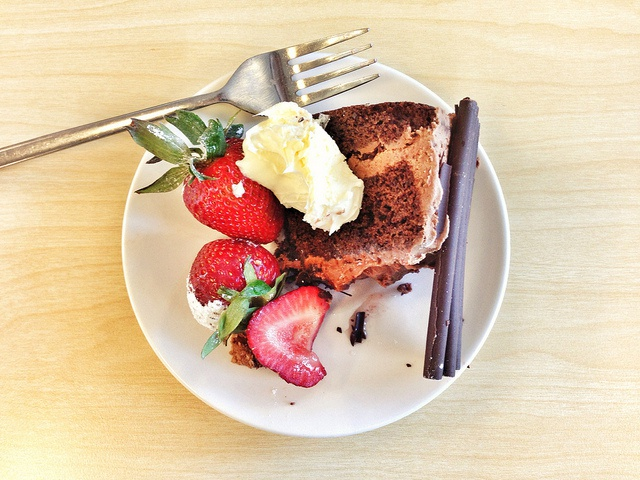Describe the objects in this image and their specific colors. I can see dining table in beige and tan tones, cake in beige, ivory, maroon, khaki, and black tones, and fork in beige, ivory, tan, and darkgray tones in this image. 